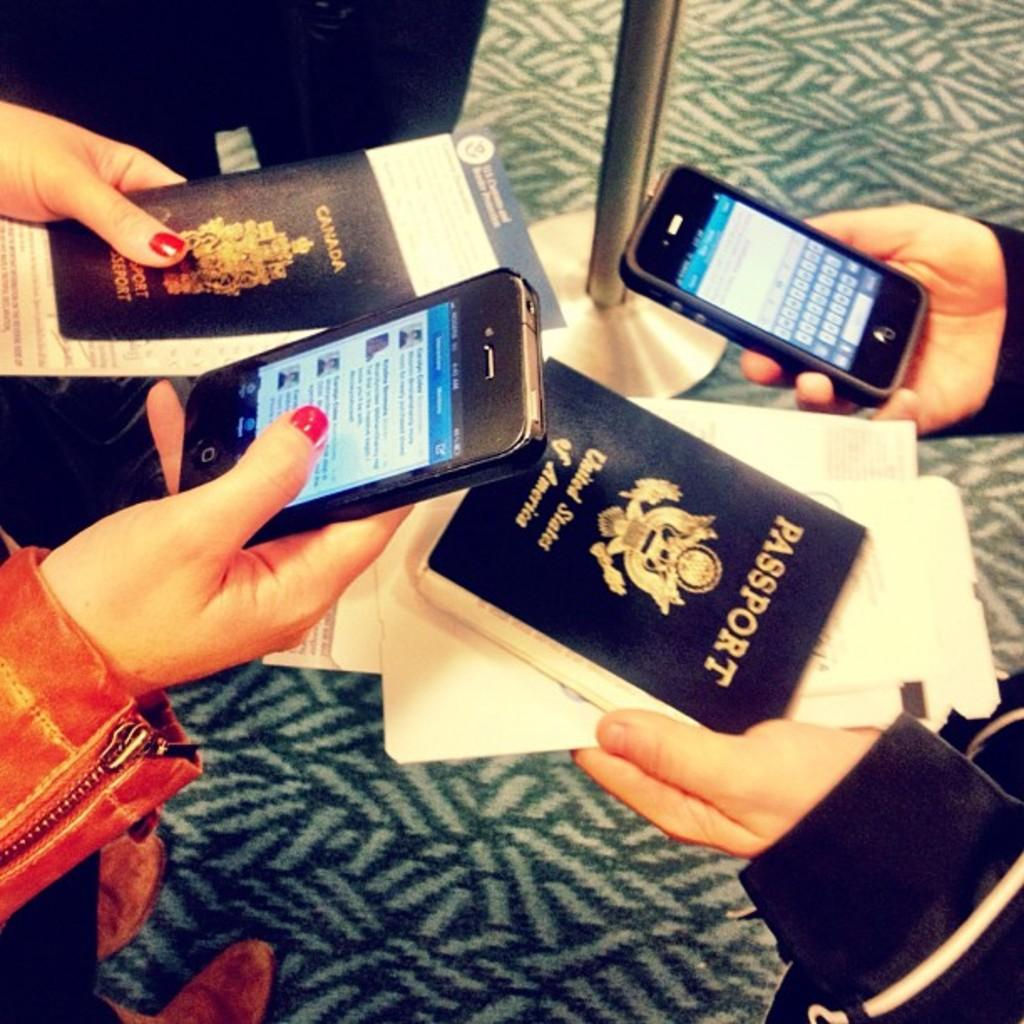<image>
Share a concise interpretation of the image provided. Two people holding two phones and two passports. 